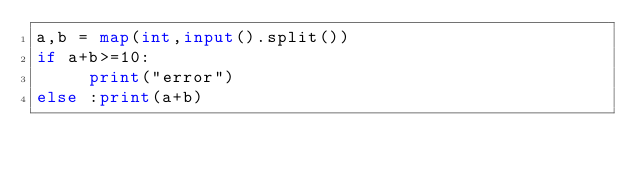<code> <loc_0><loc_0><loc_500><loc_500><_Python_>a,b = map(int,input().split())
if a+b>=10:
     print("error")
else :print(a+b)
</code> 